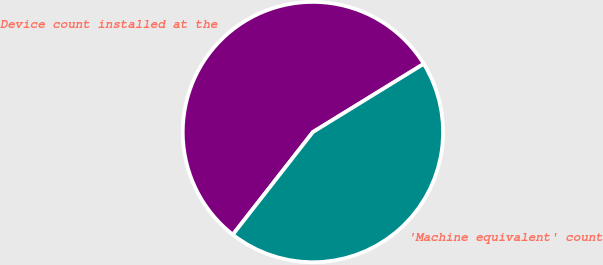Convert chart. <chart><loc_0><loc_0><loc_500><loc_500><pie_chart><fcel>Device count installed at the<fcel>'Machine equivalent' count<nl><fcel>55.67%<fcel>44.33%<nl></chart> 